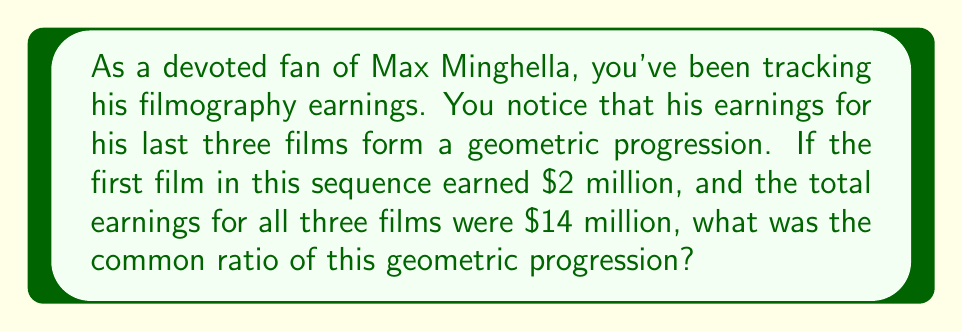Solve this math problem. Let's approach this step-by-step:

1) Let $r$ be the common ratio of the geometric progression.

2) Given:
   - The first term, $a = 2$ million
   - The sum of three terms, $S_3 = 14$ million

3) In a geometric progression, the three terms would be $a$, $ar$, and $ar^2$.

4) The sum of a geometric progression is given by the formula:

   $$S_n = \frac{a(1-r^n)}{1-r}$$

   where $n$ is the number of terms.

5) Substituting our known values:

   $$14 = \frac{2(1-r^3)}{1-r}$$

6) Multiply both sides by $(1-r)$:

   $$14(1-r) = 2(1-r^3)$$

7) Expand:

   $$14 - 14r = 2 - 2r^3$$

8) Rearrange:

   $$2r^3 - 14r + 12 = 0$$

9) Divide by 2:

   $$r^3 - 7r + 6 = 0$$

10) This can be factored as:

    $$(r-1)(r-2)(r-3) = 0$$

11) The solutions are $r = 1$, $r = 2$, or $r = 3$.

12) Since this is a growing progression (total is more than 3 times the first term), $r$ must be greater than 1.

13) We can verify: If $r = 2$, then the terms would be 2, 4, and 8, which sum to 14 million.

Therefore, the common ratio is 2.
Answer: The common ratio of the geometric progression is 2. 